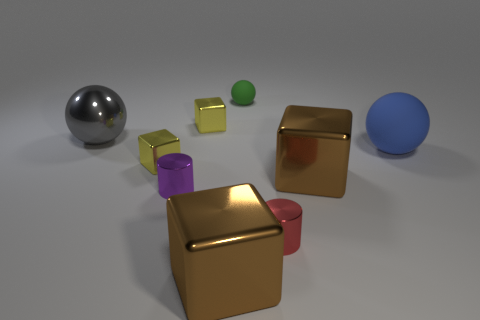Subtract all large spheres. How many spheres are left? 1 Subtract all purple balls. How many yellow blocks are left? 2 Add 1 red shiny cylinders. How many objects exist? 10 Subtract all gray spheres. How many spheres are left? 2 Subtract all cubes. How many objects are left? 5 Subtract 3 cubes. How many cubes are left? 1 Subtract all green cylinders. Subtract all blue balls. How many cylinders are left? 2 Subtract all blue balls. Subtract all metallic cylinders. How many objects are left? 6 Add 7 purple shiny objects. How many purple shiny objects are left? 8 Add 9 big blue matte spheres. How many big blue matte spheres exist? 10 